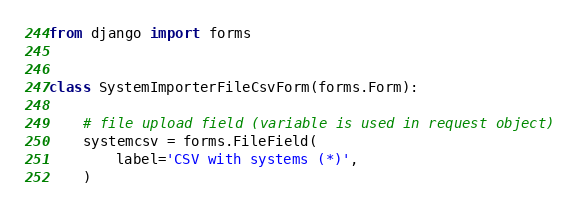<code> <loc_0><loc_0><loc_500><loc_500><_Python_>from django import forms


class SystemImporterFileCsvForm(forms.Form):

    # file upload field (variable is used in request object)
    systemcsv = forms.FileField(
        label='CSV with systems (*)',
    )
</code> 